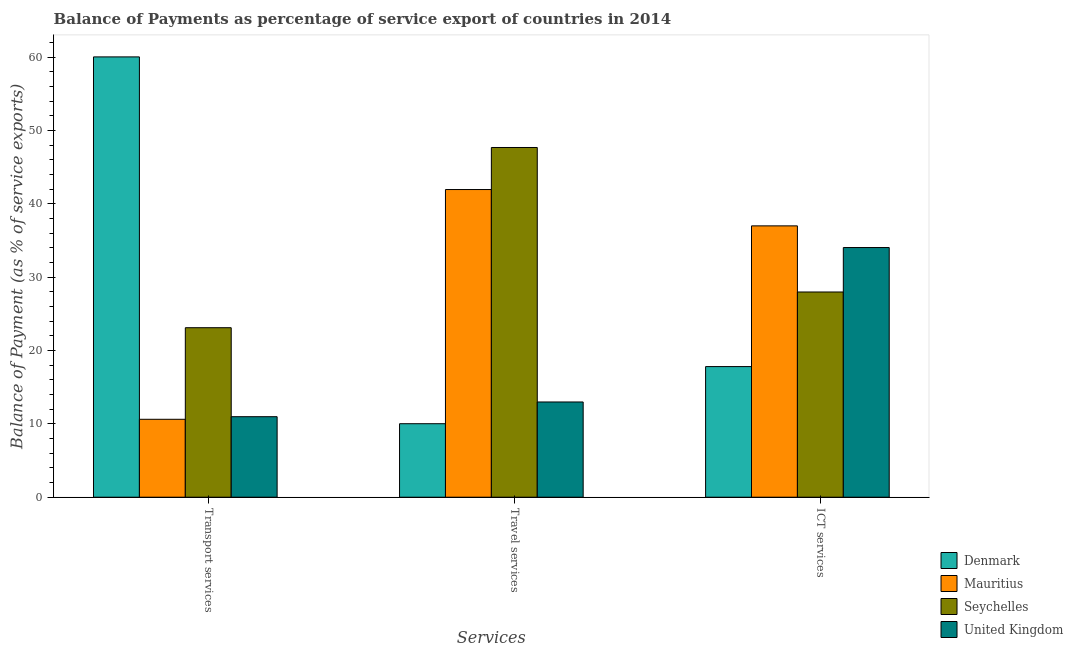How many different coloured bars are there?
Your answer should be compact. 4. How many groups of bars are there?
Offer a very short reply. 3. How many bars are there on the 1st tick from the right?
Your answer should be compact. 4. What is the label of the 1st group of bars from the left?
Provide a succinct answer. Transport services. What is the balance of payment of transport services in Denmark?
Your response must be concise. 60.03. Across all countries, what is the maximum balance of payment of ict services?
Your answer should be compact. 36.99. Across all countries, what is the minimum balance of payment of ict services?
Make the answer very short. 17.81. In which country was the balance of payment of transport services minimum?
Your answer should be very brief. Mauritius. What is the total balance of payment of travel services in the graph?
Provide a short and direct response. 112.63. What is the difference between the balance of payment of transport services in Mauritius and that in Seychelles?
Provide a succinct answer. -12.49. What is the difference between the balance of payment of travel services in Mauritius and the balance of payment of transport services in United Kingdom?
Give a very brief answer. 30.97. What is the average balance of payment of travel services per country?
Your answer should be compact. 28.16. What is the difference between the balance of payment of transport services and balance of payment of travel services in Denmark?
Your answer should be compact. 50.01. In how many countries, is the balance of payment of ict services greater than 42 %?
Offer a terse response. 0. What is the ratio of the balance of payment of transport services in United Kingdom to that in Denmark?
Provide a succinct answer. 0.18. Is the balance of payment of transport services in Mauritius less than that in Seychelles?
Your response must be concise. Yes. What is the difference between the highest and the second highest balance of payment of transport services?
Keep it short and to the point. 36.92. What is the difference between the highest and the lowest balance of payment of transport services?
Your response must be concise. 49.41. In how many countries, is the balance of payment of travel services greater than the average balance of payment of travel services taken over all countries?
Provide a short and direct response. 2. What does the 4th bar from the right in Transport services represents?
Offer a terse response. Denmark. Is it the case that in every country, the sum of the balance of payment of transport services and balance of payment of travel services is greater than the balance of payment of ict services?
Provide a succinct answer. No. Does the graph contain grids?
Give a very brief answer. No. How many legend labels are there?
Keep it short and to the point. 4. What is the title of the graph?
Provide a short and direct response. Balance of Payments as percentage of service export of countries in 2014. Does "Vietnam" appear as one of the legend labels in the graph?
Provide a short and direct response. No. What is the label or title of the X-axis?
Give a very brief answer. Services. What is the label or title of the Y-axis?
Keep it short and to the point. Balance of Payment (as % of service exports). What is the Balance of Payment (as % of service exports) of Denmark in Transport services?
Your answer should be very brief. 60.03. What is the Balance of Payment (as % of service exports) in Mauritius in Transport services?
Make the answer very short. 10.62. What is the Balance of Payment (as % of service exports) in Seychelles in Transport services?
Offer a very short reply. 23.11. What is the Balance of Payment (as % of service exports) of United Kingdom in Transport services?
Make the answer very short. 10.98. What is the Balance of Payment (as % of service exports) in Denmark in Travel services?
Give a very brief answer. 10.02. What is the Balance of Payment (as % of service exports) of Mauritius in Travel services?
Keep it short and to the point. 41.95. What is the Balance of Payment (as % of service exports) of Seychelles in Travel services?
Ensure brevity in your answer.  47.68. What is the Balance of Payment (as % of service exports) in United Kingdom in Travel services?
Give a very brief answer. 12.98. What is the Balance of Payment (as % of service exports) of Denmark in ICT services?
Your answer should be compact. 17.81. What is the Balance of Payment (as % of service exports) in Mauritius in ICT services?
Ensure brevity in your answer.  36.99. What is the Balance of Payment (as % of service exports) of Seychelles in ICT services?
Make the answer very short. 27.98. What is the Balance of Payment (as % of service exports) of United Kingdom in ICT services?
Your response must be concise. 34.04. Across all Services, what is the maximum Balance of Payment (as % of service exports) in Denmark?
Ensure brevity in your answer.  60.03. Across all Services, what is the maximum Balance of Payment (as % of service exports) in Mauritius?
Your answer should be very brief. 41.95. Across all Services, what is the maximum Balance of Payment (as % of service exports) of Seychelles?
Provide a short and direct response. 47.68. Across all Services, what is the maximum Balance of Payment (as % of service exports) in United Kingdom?
Make the answer very short. 34.04. Across all Services, what is the minimum Balance of Payment (as % of service exports) of Denmark?
Offer a terse response. 10.02. Across all Services, what is the minimum Balance of Payment (as % of service exports) of Mauritius?
Offer a very short reply. 10.62. Across all Services, what is the minimum Balance of Payment (as % of service exports) in Seychelles?
Your answer should be very brief. 23.11. Across all Services, what is the minimum Balance of Payment (as % of service exports) in United Kingdom?
Keep it short and to the point. 10.98. What is the total Balance of Payment (as % of service exports) of Denmark in the graph?
Provide a short and direct response. 87.86. What is the total Balance of Payment (as % of service exports) in Mauritius in the graph?
Ensure brevity in your answer.  89.56. What is the total Balance of Payment (as % of service exports) of Seychelles in the graph?
Your answer should be very brief. 98.77. What is the total Balance of Payment (as % of service exports) of United Kingdom in the graph?
Offer a very short reply. 58. What is the difference between the Balance of Payment (as % of service exports) in Denmark in Transport services and that in Travel services?
Offer a very short reply. 50.01. What is the difference between the Balance of Payment (as % of service exports) in Mauritius in Transport services and that in Travel services?
Provide a succinct answer. -31.32. What is the difference between the Balance of Payment (as % of service exports) of Seychelles in Transport services and that in Travel services?
Offer a very short reply. -24.57. What is the difference between the Balance of Payment (as % of service exports) in United Kingdom in Transport services and that in Travel services?
Provide a short and direct response. -2.01. What is the difference between the Balance of Payment (as % of service exports) of Denmark in Transport services and that in ICT services?
Provide a short and direct response. 42.22. What is the difference between the Balance of Payment (as % of service exports) of Mauritius in Transport services and that in ICT services?
Offer a very short reply. -26.37. What is the difference between the Balance of Payment (as % of service exports) in Seychelles in Transport services and that in ICT services?
Give a very brief answer. -4.87. What is the difference between the Balance of Payment (as % of service exports) in United Kingdom in Transport services and that in ICT services?
Offer a very short reply. -23.06. What is the difference between the Balance of Payment (as % of service exports) of Denmark in Travel services and that in ICT services?
Make the answer very short. -7.79. What is the difference between the Balance of Payment (as % of service exports) in Mauritius in Travel services and that in ICT services?
Keep it short and to the point. 4.95. What is the difference between the Balance of Payment (as % of service exports) in Seychelles in Travel services and that in ICT services?
Give a very brief answer. 19.7. What is the difference between the Balance of Payment (as % of service exports) of United Kingdom in Travel services and that in ICT services?
Provide a short and direct response. -21.06. What is the difference between the Balance of Payment (as % of service exports) in Denmark in Transport services and the Balance of Payment (as % of service exports) in Mauritius in Travel services?
Your response must be concise. 18.08. What is the difference between the Balance of Payment (as % of service exports) of Denmark in Transport services and the Balance of Payment (as % of service exports) of Seychelles in Travel services?
Your answer should be compact. 12.35. What is the difference between the Balance of Payment (as % of service exports) in Denmark in Transport services and the Balance of Payment (as % of service exports) in United Kingdom in Travel services?
Make the answer very short. 47.05. What is the difference between the Balance of Payment (as % of service exports) in Mauritius in Transport services and the Balance of Payment (as % of service exports) in Seychelles in Travel services?
Keep it short and to the point. -37.05. What is the difference between the Balance of Payment (as % of service exports) in Mauritius in Transport services and the Balance of Payment (as % of service exports) in United Kingdom in Travel services?
Keep it short and to the point. -2.36. What is the difference between the Balance of Payment (as % of service exports) in Seychelles in Transport services and the Balance of Payment (as % of service exports) in United Kingdom in Travel services?
Provide a short and direct response. 10.13. What is the difference between the Balance of Payment (as % of service exports) in Denmark in Transport services and the Balance of Payment (as % of service exports) in Mauritius in ICT services?
Keep it short and to the point. 23.04. What is the difference between the Balance of Payment (as % of service exports) in Denmark in Transport services and the Balance of Payment (as % of service exports) in Seychelles in ICT services?
Keep it short and to the point. 32.05. What is the difference between the Balance of Payment (as % of service exports) of Denmark in Transport services and the Balance of Payment (as % of service exports) of United Kingdom in ICT services?
Ensure brevity in your answer.  25.99. What is the difference between the Balance of Payment (as % of service exports) of Mauritius in Transport services and the Balance of Payment (as % of service exports) of Seychelles in ICT services?
Your answer should be compact. -17.36. What is the difference between the Balance of Payment (as % of service exports) in Mauritius in Transport services and the Balance of Payment (as % of service exports) in United Kingdom in ICT services?
Offer a terse response. -23.42. What is the difference between the Balance of Payment (as % of service exports) in Seychelles in Transport services and the Balance of Payment (as % of service exports) in United Kingdom in ICT services?
Ensure brevity in your answer.  -10.93. What is the difference between the Balance of Payment (as % of service exports) in Denmark in Travel services and the Balance of Payment (as % of service exports) in Mauritius in ICT services?
Keep it short and to the point. -26.97. What is the difference between the Balance of Payment (as % of service exports) of Denmark in Travel services and the Balance of Payment (as % of service exports) of Seychelles in ICT services?
Ensure brevity in your answer.  -17.96. What is the difference between the Balance of Payment (as % of service exports) of Denmark in Travel services and the Balance of Payment (as % of service exports) of United Kingdom in ICT services?
Offer a very short reply. -24.02. What is the difference between the Balance of Payment (as % of service exports) in Mauritius in Travel services and the Balance of Payment (as % of service exports) in Seychelles in ICT services?
Provide a succinct answer. 13.97. What is the difference between the Balance of Payment (as % of service exports) of Mauritius in Travel services and the Balance of Payment (as % of service exports) of United Kingdom in ICT services?
Your answer should be very brief. 7.91. What is the difference between the Balance of Payment (as % of service exports) of Seychelles in Travel services and the Balance of Payment (as % of service exports) of United Kingdom in ICT services?
Give a very brief answer. 13.64. What is the average Balance of Payment (as % of service exports) in Denmark per Services?
Provide a succinct answer. 29.29. What is the average Balance of Payment (as % of service exports) in Mauritius per Services?
Your answer should be compact. 29.85. What is the average Balance of Payment (as % of service exports) of Seychelles per Services?
Provide a short and direct response. 32.92. What is the average Balance of Payment (as % of service exports) in United Kingdom per Services?
Ensure brevity in your answer.  19.33. What is the difference between the Balance of Payment (as % of service exports) of Denmark and Balance of Payment (as % of service exports) of Mauritius in Transport services?
Your response must be concise. 49.41. What is the difference between the Balance of Payment (as % of service exports) in Denmark and Balance of Payment (as % of service exports) in Seychelles in Transport services?
Your response must be concise. 36.92. What is the difference between the Balance of Payment (as % of service exports) of Denmark and Balance of Payment (as % of service exports) of United Kingdom in Transport services?
Offer a terse response. 49.05. What is the difference between the Balance of Payment (as % of service exports) of Mauritius and Balance of Payment (as % of service exports) of Seychelles in Transport services?
Your answer should be very brief. -12.49. What is the difference between the Balance of Payment (as % of service exports) of Mauritius and Balance of Payment (as % of service exports) of United Kingdom in Transport services?
Give a very brief answer. -0.35. What is the difference between the Balance of Payment (as % of service exports) in Seychelles and Balance of Payment (as % of service exports) in United Kingdom in Transport services?
Ensure brevity in your answer.  12.13. What is the difference between the Balance of Payment (as % of service exports) in Denmark and Balance of Payment (as % of service exports) in Mauritius in Travel services?
Give a very brief answer. -31.93. What is the difference between the Balance of Payment (as % of service exports) of Denmark and Balance of Payment (as % of service exports) of Seychelles in Travel services?
Your response must be concise. -37.66. What is the difference between the Balance of Payment (as % of service exports) in Denmark and Balance of Payment (as % of service exports) in United Kingdom in Travel services?
Provide a short and direct response. -2.96. What is the difference between the Balance of Payment (as % of service exports) in Mauritius and Balance of Payment (as % of service exports) in Seychelles in Travel services?
Your answer should be compact. -5.73. What is the difference between the Balance of Payment (as % of service exports) in Mauritius and Balance of Payment (as % of service exports) in United Kingdom in Travel services?
Ensure brevity in your answer.  28.96. What is the difference between the Balance of Payment (as % of service exports) of Seychelles and Balance of Payment (as % of service exports) of United Kingdom in Travel services?
Make the answer very short. 34.69. What is the difference between the Balance of Payment (as % of service exports) in Denmark and Balance of Payment (as % of service exports) in Mauritius in ICT services?
Give a very brief answer. -19.18. What is the difference between the Balance of Payment (as % of service exports) of Denmark and Balance of Payment (as % of service exports) of Seychelles in ICT services?
Give a very brief answer. -10.17. What is the difference between the Balance of Payment (as % of service exports) in Denmark and Balance of Payment (as % of service exports) in United Kingdom in ICT services?
Offer a terse response. -16.23. What is the difference between the Balance of Payment (as % of service exports) of Mauritius and Balance of Payment (as % of service exports) of Seychelles in ICT services?
Your response must be concise. 9.01. What is the difference between the Balance of Payment (as % of service exports) of Mauritius and Balance of Payment (as % of service exports) of United Kingdom in ICT services?
Provide a succinct answer. 2.95. What is the difference between the Balance of Payment (as % of service exports) in Seychelles and Balance of Payment (as % of service exports) in United Kingdom in ICT services?
Ensure brevity in your answer.  -6.06. What is the ratio of the Balance of Payment (as % of service exports) in Denmark in Transport services to that in Travel services?
Keep it short and to the point. 5.99. What is the ratio of the Balance of Payment (as % of service exports) of Mauritius in Transport services to that in Travel services?
Your answer should be very brief. 0.25. What is the ratio of the Balance of Payment (as % of service exports) of Seychelles in Transport services to that in Travel services?
Make the answer very short. 0.48. What is the ratio of the Balance of Payment (as % of service exports) in United Kingdom in Transport services to that in Travel services?
Your answer should be compact. 0.85. What is the ratio of the Balance of Payment (as % of service exports) in Denmark in Transport services to that in ICT services?
Make the answer very short. 3.37. What is the ratio of the Balance of Payment (as % of service exports) in Mauritius in Transport services to that in ICT services?
Ensure brevity in your answer.  0.29. What is the ratio of the Balance of Payment (as % of service exports) in Seychelles in Transport services to that in ICT services?
Your response must be concise. 0.83. What is the ratio of the Balance of Payment (as % of service exports) of United Kingdom in Transport services to that in ICT services?
Make the answer very short. 0.32. What is the ratio of the Balance of Payment (as % of service exports) of Denmark in Travel services to that in ICT services?
Ensure brevity in your answer.  0.56. What is the ratio of the Balance of Payment (as % of service exports) in Mauritius in Travel services to that in ICT services?
Keep it short and to the point. 1.13. What is the ratio of the Balance of Payment (as % of service exports) of Seychelles in Travel services to that in ICT services?
Your answer should be compact. 1.7. What is the ratio of the Balance of Payment (as % of service exports) of United Kingdom in Travel services to that in ICT services?
Your answer should be very brief. 0.38. What is the difference between the highest and the second highest Balance of Payment (as % of service exports) in Denmark?
Give a very brief answer. 42.22. What is the difference between the highest and the second highest Balance of Payment (as % of service exports) of Mauritius?
Provide a short and direct response. 4.95. What is the difference between the highest and the second highest Balance of Payment (as % of service exports) of Seychelles?
Your answer should be compact. 19.7. What is the difference between the highest and the second highest Balance of Payment (as % of service exports) in United Kingdom?
Your answer should be very brief. 21.06. What is the difference between the highest and the lowest Balance of Payment (as % of service exports) in Denmark?
Make the answer very short. 50.01. What is the difference between the highest and the lowest Balance of Payment (as % of service exports) of Mauritius?
Offer a very short reply. 31.32. What is the difference between the highest and the lowest Balance of Payment (as % of service exports) in Seychelles?
Your response must be concise. 24.57. What is the difference between the highest and the lowest Balance of Payment (as % of service exports) of United Kingdom?
Give a very brief answer. 23.06. 